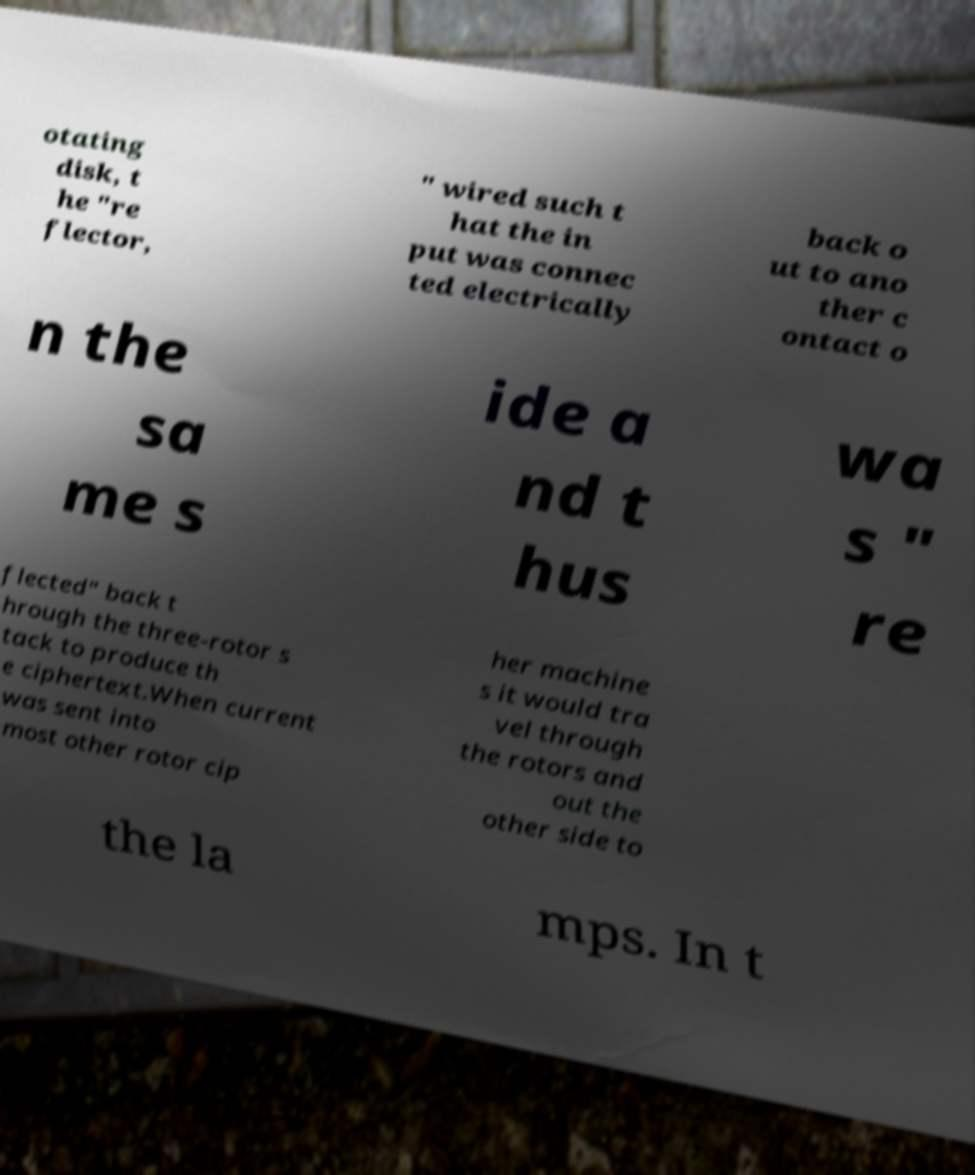What messages or text are displayed in this image? I need them in a readable, typed format. otating disk, t he "re flector, " wired such t hat the in put was connec ted electrically back o ut to ano ther c ontact o n the sa me s ide a nd t hus wa s " re flected" back t hrough the three-rotor s tack to produce th e ciphertext.When current was sent into most other rotor cip her machine s it would tra vel through the rotors and out the other side to the la mps. In t 